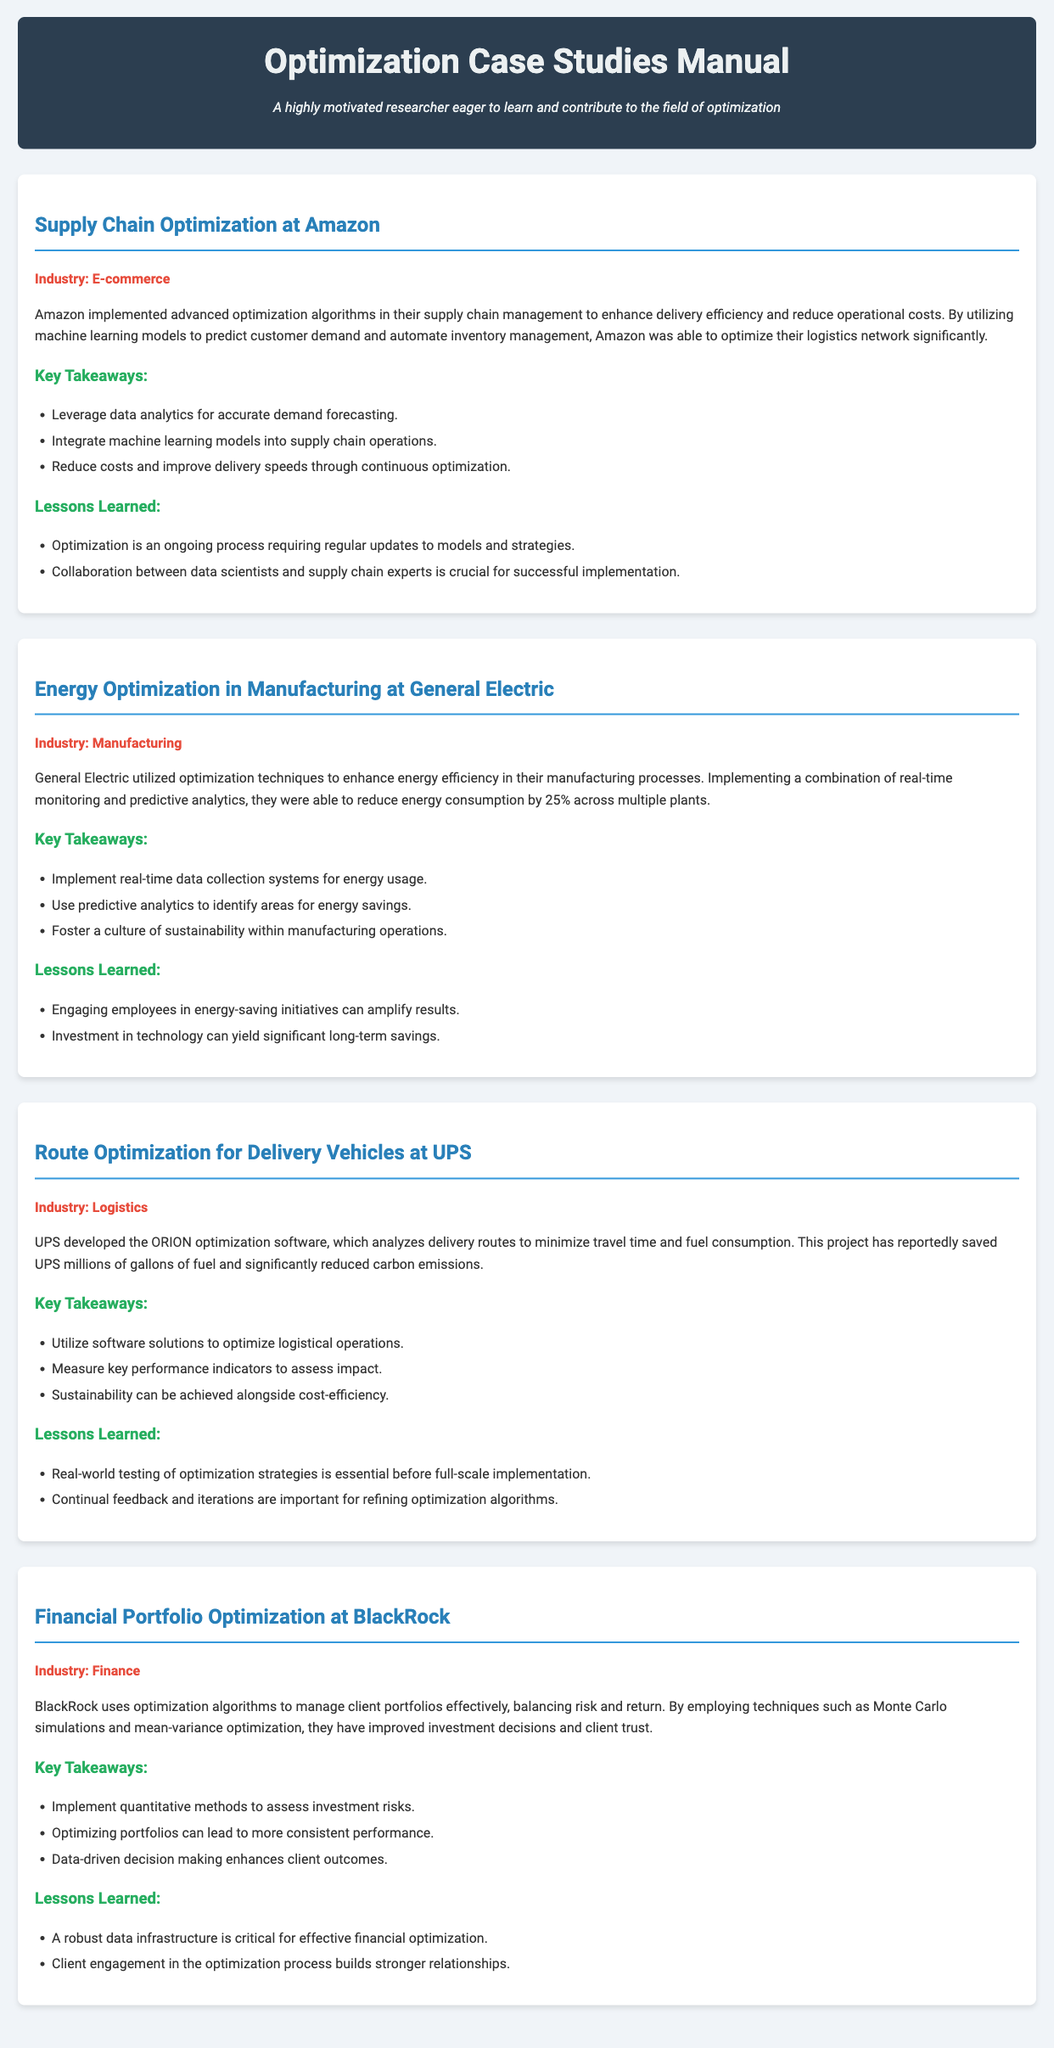What optimization technique did Amazon use in their supply chain management? Amazon utilized advanced optimization algorithms to enhance delivery efficiency and reduce operational costs in their supply chain management.
Answer: Advanced optimization algorithms By how much did General Electric reduce energy consumption in manufacturing? General Electric reduced energy consumption by 25% across multiple plants through optimization techniques.
Answer: 25% What software did UPS develop for route optimization? UPS developed the ORION optimization software to analyze delivery routes for minimizing travel time and fuel consumption.
Answer: ORION Which financial optimization techniques does BlackRock employ? BlackRock employs techniques such as Monte Carlo simulations and mean-variance optimization for managing client portfolios effectively.
Answer: Monte Carlo simulations and mean-variance optimization What was a key takeaway from the energy optimization case at General Electric? A key takeaway from General Electric's energy optimization case was to implement real-time data collection systems for energy usage.
Answer: Implement real-time data collection systems for energy usage How does UPS measure the impact of their route optimization? UPS measures the impact of their route optimization by utilizing key performance indicators.
Answer: Key performance indicators What type of document is this? The document is a manual detailing case studies that highlight successful applications of optimization in various industries.
Answer: Manual What industry does the case study on BlackRock belong to? The case study on BlackRock is in the finance industry.
Answer: Finance 